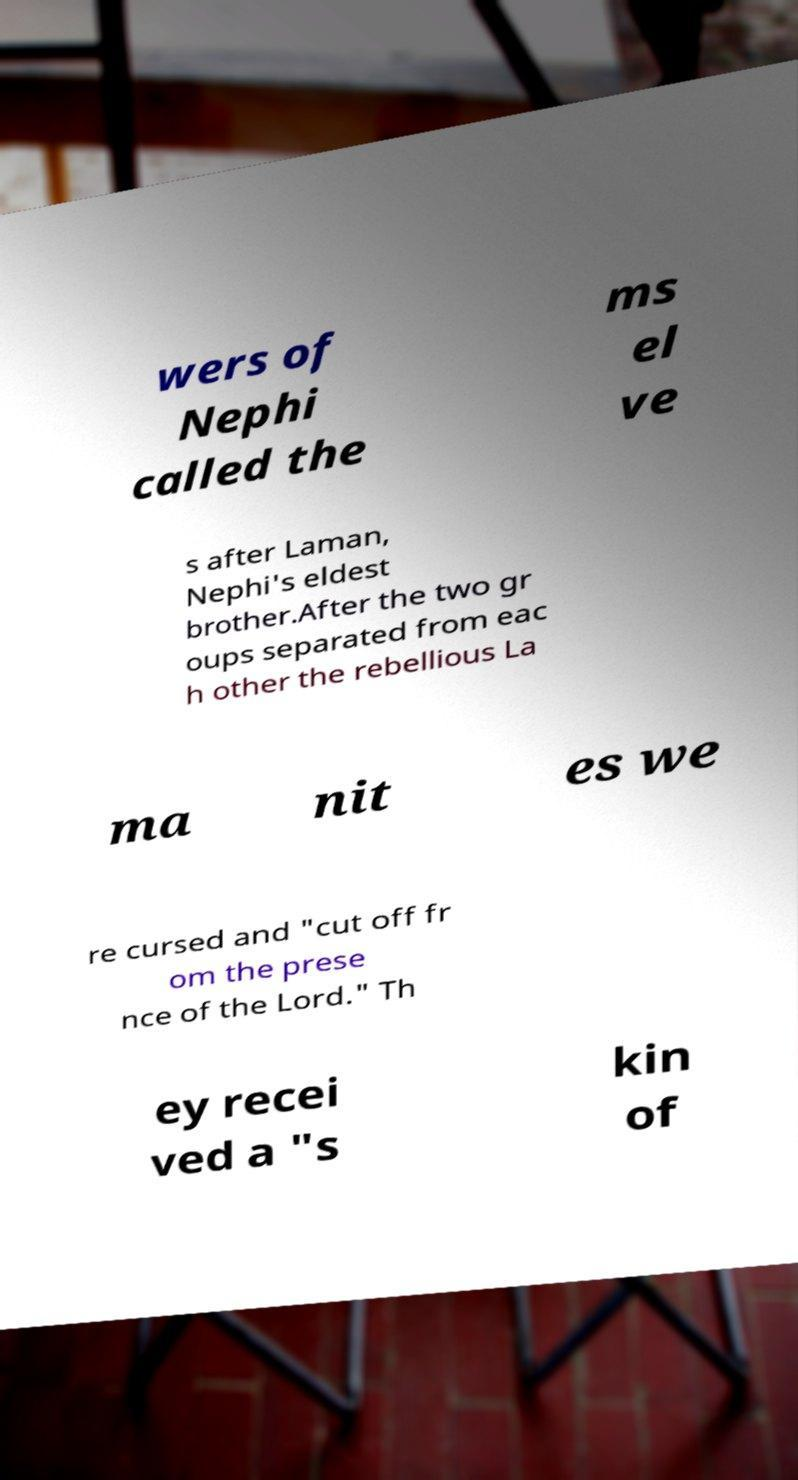Could you extract and type out the text from this image? wers of Nephi called the ms el ve s after Laman, Nephi's eldest brother.After the two gr oups separated from eac h other the rebellious La ma nit es we re cursed and "cut off fr om the prese nce of the Lord." Th ey recei ved a "s kin of 